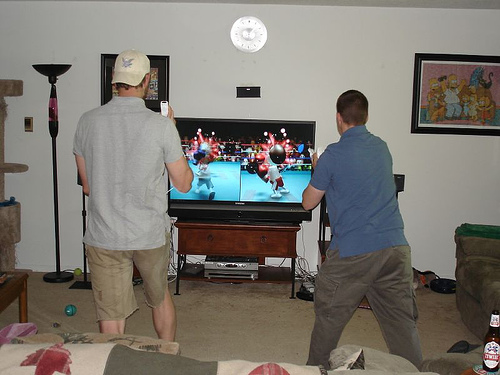<image>Insignia of closest hat is for what sport? It is unknown what sport the insignia on the closest hat represents. It could represent various sports such as boxing, soccer, aero, golf, or baseball. What letter is on the man's hat? I don't know what letter is on the man's hat. There might be no letter at all. Insignia of closest hat is for what sport? I am not sure what sport the insignia of the closest hat is for. It can be boxing, soccer, aero, golf, or baseball. What letter is on the man's hat? I don't know. There are different answers given: 'w', 'ny', 'bird', 'v', 's'. 